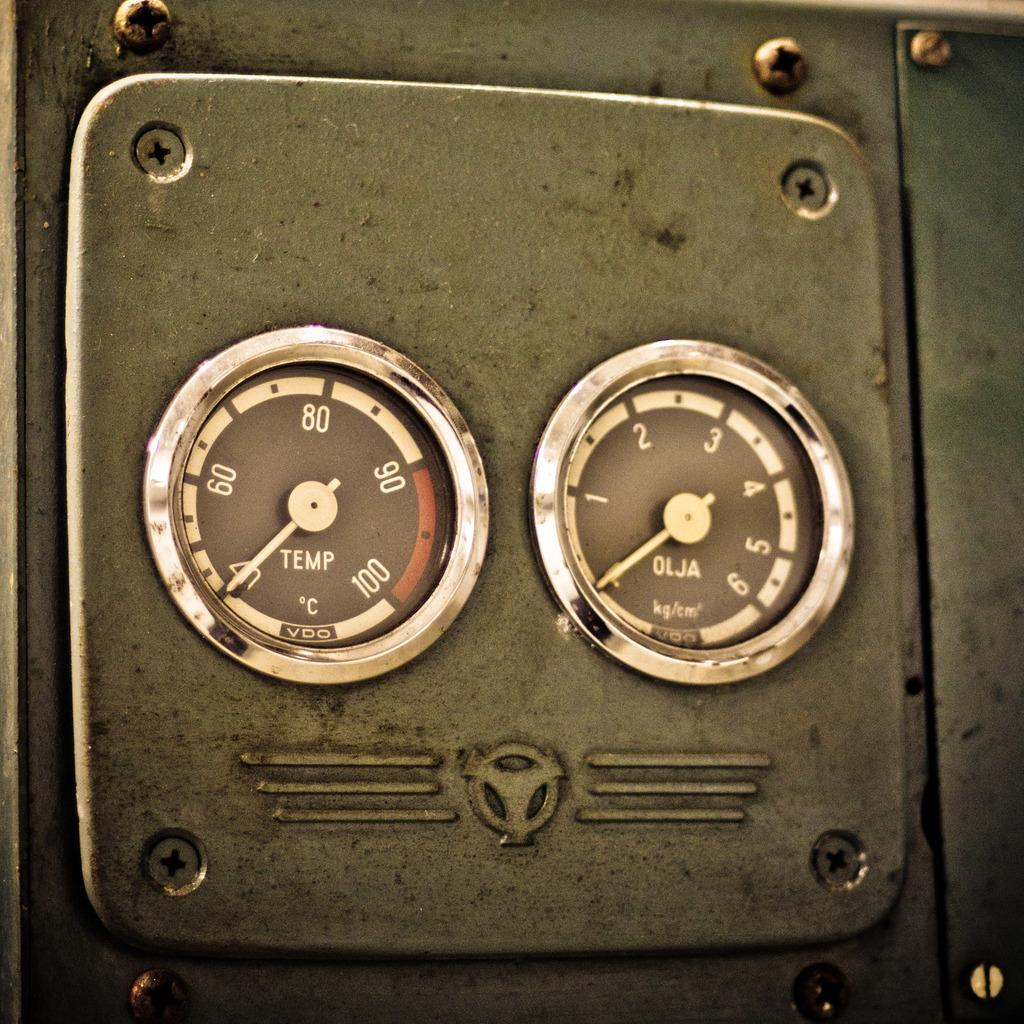What object in the image has meter readings? There is an instrument in the image that has meter readings. Can you describe the instrument in the image? The instrument in the image has meter readings, but without more information, it is difficult to provide a detailed description. What type of sack is being used to carry the instrument in the image? There is no sack present in the image; the instrument is not being carried. 